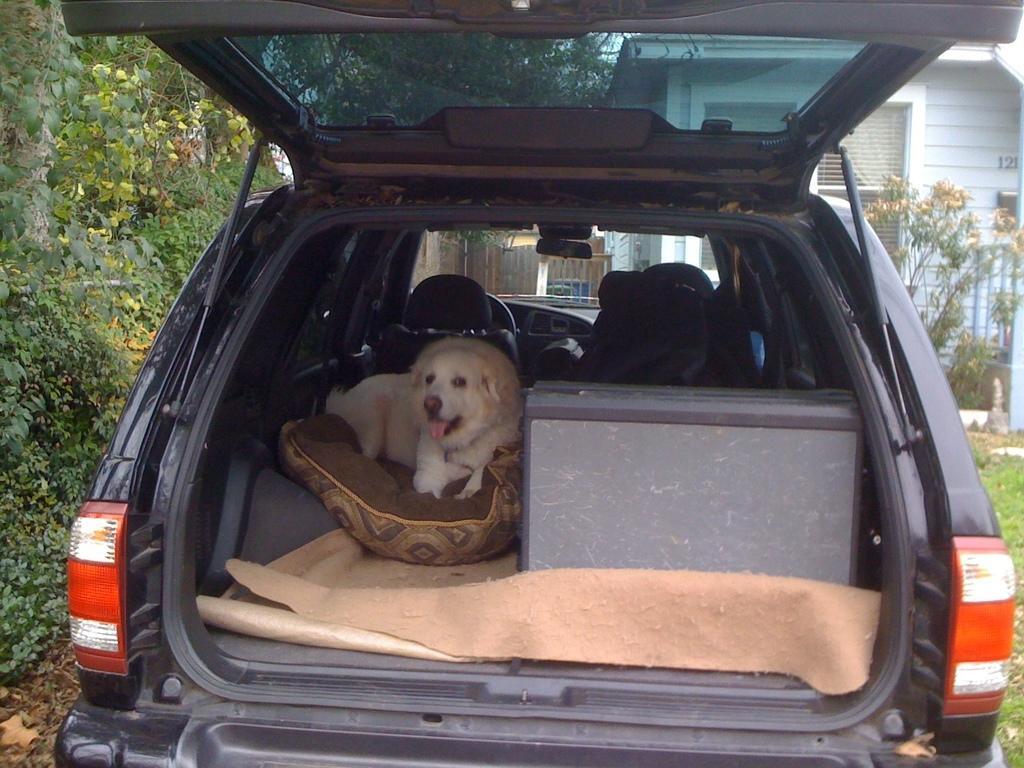Could you give a brief overview of what you see in this image? The image is inside the car. Inside the car we can see a dog lying on pillow on right side there is a box. On left side there are some trees, on right side there is a building and windows which are closed, in background there is a gate. 